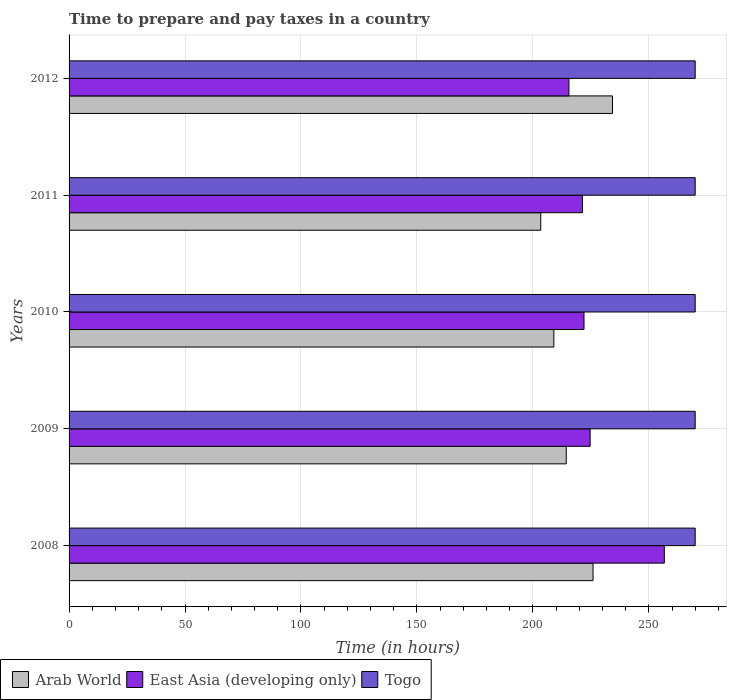How many different coloured bars are there?
Your answer should be very brief. 3. How many groups of bars are there?
Keep it short and to the point. 5. Are the number of bars per tick equal to the number of legend labels?
Ensure brevity in your answer.  Yes. Are the number of bars on each tick of the Y-axis equal?
Offer a very short reply. Yes. How many bars are there on the 3rd tick from the top?
Your response must be concise. 3. How many bars are there on the 4th tick from the bottom?
Your response must be concise. 3. What is the label of the 5th group of bars from the top?
Keep it short and to the point. 2008. In how many cases, is the number of bars for a given year not equal to the number of legend labels?
Provide a succinct answer. 0. What is the number of hours required to prepare and pay taxes in East Asia (developing only) in 2012?
Your answer should be compact. 215.55. Across all years, what is the maximum number of hours required to prepare and pay taxes in Togo?
Give a very brief answer. 270. Across all years, what is the minimum number of hours required to prepare and pay taxes in Arab World?
Your response must be concise. 203.4. What is the total number of hours required to prepare and pay taxes in Togo in the graph?
Give a very brief answer. 1350. What is the difference between the number of hours required to prepare and pay taxes in East Asia (developing only) in 2010 and that in 2011?
Give a very brief answer. 0.67. What is the difference between the number of hours required to prepare and pay taxes in Togo in 2010 and the number of hours required to prepare and pay taxes in East Asia (developing only) in 2012?
Ensure brevity in your answer.  54.45. What is the average number of hours required to prepare and pay taxes in Togo per year?
Make the answer very short. 270. In the year 2010, what is the difference between the number of hours required to prepare and pay taxes in Togo and number of hours required to prepare and pay taxes in Arab World?
Your answer should be very brief. 60.95. What is the ratio of the number of hours required to prepare and pay taxes in East Asia (developing only) in 2008 to that in 2010?
Ensure brevity in your answer.  1.16. What is the difference between the highest and the second highest number of hours required to prepare and pay taxes in East Asia (developing only)?
Give a very brief answer. 32. What is the difference between the highest and the lowest number of hours required to prepare and pay taxes in East Asia (developing only)?
Provide a short and direct response. 41.14. In how many years, is the number of hours required to prepare and pay taxes in Arab World greater than the average number of hours required to prepare and pay taxes in Arab World taken over all years?
Offer a terse response. 2. What does the 1st bar from the top in 2008 represents?
Give a very brief answer. Togo. What does the 1st bar from the bottom in 2010 represents?
Give a very brief answer. Arab World. How many bars are there?
Offer a terse response. 15. Are all the bars in the graph horizontal?
Your response must be concise. Yes. What is the difference between two consecutive major ticks on the X-axis?
Provide a succinct answer. 50. Does the graph contain grids?
Keep it short and to the point. Yes. Where does the legend appear in the graph?
Provide a succinct answer. Bottom left. How many legend labels are there?
Offer a terse response. 3. What is the title of the graph?
Provide a succinct answer. Time to prepare and pay taxes in a country. What is the label or title of the X-axis?
Provide a succinct answer. Time (in hours). What is the label or title of the Y-axis?
Your answer should be very brief. Years. What is the Time (in hours) of Arab World in 2008?
Make the answer very short. 225.95. What is the Time (in hours) of East Asia (developing only) in 2008?
Ensure brevity in your answer.  256.69. What is the Time (in hours) of Togo in 2008?
Give a very brief answer. 270. What is the Time (in hours) of Arab World in 2009?
Keep it short and to the point. 214.4. What is the Time (in hours) in East Asia (developing only) in 2009?
Keep it short and to the point. 224.69. What is the Time (in hours) in Togo in 2009?
Ensure brevity in your answer.  270. What is the Time (in hours) of Arab World in 2010?
Offer a terse response. 209.05. What is the Time (in hours) in East Asia (developing only) in 2010?
Your answer should be compact. 222.06. What is the Time (in hours) in Togo in 2010?
Ensure brevity in your answer.  270. What is the Time (in hours) of Arab World in 2011?
Make the answer very short. 203.4. What is the Time (in hours) of East Asia (developing only) in 2011?
Provide a succinct answer. 221.39. What is the Time (in hours) of Togo in 2011?
Your answer should be compact. 270. What is the Time (in hours) of Arab World in 2012?
Give a very brief answer. 234.33. What is the Time (in hours) of East Asia (developing only) in 2012?
Provide a short and direct response. 215.55. What is the Time (in hours) in Togo in 2012?
Offer a very short reply. 270. Across all years, what is the maximum Time (in hours) in Arab World?
Provide a short and direct response. 234.33. Across all years, what is the maximum Time (in hours) in East Asia (developing only)?
Your answer should be very brief. 256.69. Across all years, what is the maximum Time (in hours) in Togo?
Provide a short and direct response. 270. Across all years, what is the minimum Time (in hours) of Arab World?
Give a very brief answer. 203.4. Across all years, what is the minimum Time (in hours) in East Asia (developing only)?
Ensure brevity in your answer.  215.55. Across all years, what is the minimum Time (in hours) of Togo?
Make the answer very short. 270. What is the total Time (in hours) in Arab World in the graph?
Provide a succinct answer. 1087.13. What is the total Time (in hours) in East Asia (developing only) in the graph?
Your response must be concise. 1140.39. What is the total Time (in hours) of Togo in the graph?
Give a very brief answer. 1350. What is the difference between the Time (in hours) of Arab World in 2008 and that in 2009?
Keep it short and to the point. 11.55. What is the difference between the Time (in hours) in East Asia (developing only) in 2008 and that in 2009?
Your answer should be very brief. 32. What is the difference between the Time (in hours) in Togo in 2008 and that in 2009?
Offer a very short reply. 0. What is the difference between the Time (in hours) of East Asia (developing only) in 2008 and that in 2010?
Your answer should be compact. 34.64. What is the difference between the Time (in hours) of Togo in 2008 and that in 2010?
Offer a terse response. 0. What is the difference between the Time (in hours) in Arab World in 2008 and that in 2011?
Your response must be concise. 22.55. What is the difference between the Time (in hours) of East Asia (developing only) in 2008 and that in 2011?
Offer a terse response. 35.31. What is the difference between the Time (in hours) in Togo in 2008 and that in 2011?
Provide a short and direct response. 0. What is the difference between the Time (in hours) of Arab World in 2008 and that in 2012?
Make the answer very short. -8.38. What is the difference between the Time (in hours) of East Asia (developing only) in 2008 and that in 2012?
Provide a short and direct response. 41.14. What is the difference between the Time (in hours) of Arab World in 2009 and that in 2010?
Offer a very short reply. 5.35. What is the difference between the Time (in hours) of East Asia (developing only) in 2009 and that in 2010?
Offer a very short reply. 2.64. What is the difference between the Time (in hours) of Togo in 2009 and that in 2010?
Provide a succinct answer. 0. What is the difference between the Time (in hours) of East Asia (developing only) in 2009 and that in 2011?
Offer a very short reply. 3.31. What is the difference between the Time (in hours) of Togo in 2009 and that in 2011?
Your answer should be very brief. 0. What is the difference between the Time (in hours) in Arab World in 2009 and that in 2012?
Your answer should be compact. -19.93. What is the difference between the Time (in hours) of East Asia (developing only) in 2009 and that in 2012?
Make the answer very short. 9.14. What is the difference between the Time (in hours) of Togo in 2009 and that in 2012?
Ensure brevity in your answer.  0. What is the difference between the Time (in hours) in Arab World in 2010 and that in 2011?
Your answer should be compact. 5.65. What is the difference between the Time (in hours) in Togo in 2010 and that in 2011?
Ensure brevity in your answer.  0. What is the difference between the Time (in hours) in Arab World in 2010 and that in 2012?
Ensure brevity in your answer.  -25.28. What is the difference between the Time (in hours) of East Asia (developing only) in 2010 and that in 2012?
Provide a succinct answer. 6.5. What is the difference between the Time (in hours) in Arab World in 2011 and that in 2012?
Make the answer very short. -30.93. What is the difference between the Time (in hours) in East Asia (developing only) in 2011 and that in 2012?
Make the answer very short. 5.84. What is the difference between the Time (in hours) in Togo in 2011 and that in 2012?
Offer a terse response. 0. What is the difference between the Time (in hours) in Arab World in 2008 and the Time (in hours) in East Asia (developing only) in 2009?
Give a very brief answer. 1.26. What is the difference between the Time (in hours) of Arab World in 2008 and the Time (in hours) of Togo in 2009?
Your response must be concise. -44.05. What is the difference between the Time (in hours) in East Asia (developing only) in 2008 and the Time (in hours) in Togo in 2009?
Ensure brevity in your answer.  -13.31. What is the difference between the Time (in hours) of Arab World in 2008 and the Time (in hours) of East Asia (developing only) in 2010?
Offer a very short reply. 3.89. What is the difference between the Time (in hours) of Arab World in 2008 and the Time (in hours) of Togo in 2010?
Give a very brief answer. -44.05. What is the difference between the Time (in hours) in East Asia (developing only) in 2008 and the Time (in hours) in Togo in 2010?
Provide a succinct answer. -13.31. What is the difference between the Time (in hours) of Arab World in 2008 and the Time (in hours) of East Asia (developing only) in 2011?
Provide a succinct answer. 4.56. What is the difference between the Time (in hours) of Arab World in 2008 and the Time (in hours) of Togo in 2011?
Give a very brief answer. -44.05. What is the difference between the Time (in hours) in East Asia (developing only) in 2008 and the Time (in hours) in Togo in 2011?
Offer a terse response. -13.31. What is the difference between the Time (in hours) of Arab World in 2008 and the Time (in hours) of East Asia (developing only) in 2012?
Give a very brief answer. 10.4. What is the difference between the Time (in hours) in Arab World in 2008 and the Time (in hours) in Togo in 2012?
Ensure brevity in your answer.  -44.05. What is the difference between the Time (in hours) of East Asia (developing only) in 2008 and the Time (in hours) of Togo in 2012?
Ensure brevity in your answer.  -13.31. What is the difference between the Time (in hours) in Arab World in 2009 and the Time (in hours) in East Asia (developing only) in 2010?
Ensure brevity in your answer.  -7.66. What is the difference between the Time (in hours) in Arab World in 2009 and the Time (in hours) in Togo in 2010?
Offer a very short reply. -55.6. What is the difference between the Time (in hours) in East Asia (developing only) in 2009 and the Time (in hours) in Togo in 2010?
Your response must be concise. -45.31. What is the difference between the Time (in hours) of Arab World in 2009 and the Time (in hours) of East Asia (developing only) in 2011?
Make the answer very short. -6.99. What is the difference between the Time (in hours) of Arab World in 2009 and the Time (in hours) of Togo in 2011?
Give a very brief answer. -55.6. What is the difference between the Time (in hours) of East Asia (developing only) in 2009 and the Time (in hours) of Togo in 2011?
Make the answer very short. -45.31. What is the difference between the Time (in hours) of Arab World in 2009 and the Time (in hours) of East Asia (developing only) in 2012?
Your answer should be compact. -1.15. What is the difference between the Time (in hours) in Arab World in 2009 and the Time (in hours) in Togo in 2012?
Your response must be concise. -55.6. What is the difference between the Time (in hours) in East Asia (developing only) in 2009 and the Time (in hours) in Togo in 2012?
Offer a terse response. -45.31. What is the difference between the Time (in hours) of Arab World in 2010 and the Time (in hours) of East Asia (developing only) in 2011?
Your response must be concise. -12.34. What is the difference between the Time (in hours) of Arab World in 2010 and the Time (in hours) of Togo in 2011?
Your answer should be very brief. -60.95. What is the difference between the Time (in hours) of East Asia (developing only) in 2010 and the Time (in hours) of Togo in 2011?
Offer a very short reply. -47.94. What is the difference between the Time (in hours) of Arab World in 2010 and the Time (in hours) of East Asia (developing only) in 2012?
Ensure brevity in your answer.  -6.5. What is the difference between the Time (in hours) in Arab World in 2010 and the Time (in hours) in Togo in 2012?
Offer a terse response. -60.95. What is the difference between the Time (in hours) of East Asia (developing only) in 2010 and the Time (in hours) of Togo in 2012?
Provide a succinct answer. -47.94. What is the difference between the Time (in hours) in Arab World in 2011 and the Time (in hours) in East Asia (developing only) in 2012?
Your answer should be very brief. -12.15. What is the difference between the Time (in hours) in Arab World in 2011 and the Time (in hours) in Togo in 2012?
Your answer should be compact. -66.6. What is the difference between the Time (in hours) of East Asia (developing only) in 2011 and the Time (in hours) of Togo in 2012?
Provide a short and direct response. -48.61. What is the average Time (in hours) in Arab World per year?
Ensure brevity in your answer.  217.43. What is the average Time (in hours) in East Asia (developing only) per year?
Give a very brief answer. 228.08. What is the average Time (in hours) of Togo per year?
Make the answer very short. 270. In the year 2008, what is the difference between the Time (in hours) of Arab World and Time (in hours) of East Asia (developing only)?
Give a very brief answer. -30.74. In the year 2008, what is the difference between the Time (in hours) in Arab World and Time (in hours) in Togo?
Provide a short and direct response. -44.05. In the year 2008, what is the difference between the Time (in hours) in East Asia (developing only) and Time (in hours) in Togo?
Provide a succinct answer. -13.31. In the year 2009, what is the difference between the Time (in hours) of Arab World and Time (in hours) of East Asia (developing only)?
Provide a short and direct response. -10.29. In the year 2009, what is the difference between the Time (in hours) in Arab World and Time (in hours) in Togo?
Your response must be concise. -55.6. In the year 2009, what is the difference between the Time (in hours) in East Asia (developing only) and Time (in hours) in Togo?
Offer a very short reply. -45.31. In the year 2010, what is the difference between the Time (in hours) in Arab World and Time (in hours) in East Asia (developing only)?
Provide a succinct answer. -13.01. In the year 2010, what is the difference between the Time (in hours) in Arab World and Time (in hours) in Togo?
Make the answer very short. -60.95. In the year 2010, what is the difference between the Time (in hours) of East Asia (developing only) and Time (in hours) of Togo?
Your response must be concise. -47.94. In the year 2011, what is the difference between the Time (in hours) in Arab World and Time (in hours) in East Asia (developing only)?
Provide a short and direct response. -17.99. In the year 2011, what is the difference between the Time (in hours) of Arab World and Time (in hours) of Togo?
Give a very brief answer. -66.6. In the year 2011, what is the difference between the Time (in hours) in East Asia (developing only) and Time (in hours) in Togo?
Provide a succinct answer. -48.61. In the year 2012, what is the difference between the Time (in hours) of Arab World and Time (in hours) of East Asia (developing only)?
Your response must be concise. 18.78. In the year 2012, what is the difference between the Time (in hours) of Arab World and Time (in hours) of Togo?
Offer a terse response. -35.67. In the year 2012, what is the difference between the Time (in hours) of East Asia (developing only) and Time (in hours) of Togo?
Provide a short and direct response. -54.45. What is the ratio of the Time (in hours) in Arab World in 2008 to that in 2009?
Your answer should be compact. 1.05. What is the ratio of the Time (in hours) of East Asia (developing only) in 2008 to that in 2009?
Ensure brevity in your answer.  1.14. What is the ratio of the Time (in hours) of Togo in 2008 to that in 2009?
Provide a short and direct response. 1. What is the ratio of the Time (in hours) in Arab World in 2008 to that in 2010?
Keep it short and to the point. 1.08. What is the ratio of the Time (in hours) of East Asia (developing only) in 2008 to that in 2010?
Keep it short and to the point. 1.16. What is the ratio of the Time (in hours) in Arab World in 2008 to that in 2011?
Keep it short and to the point. 1.11. What is the ratio of the Time (in hours) of East Asia (developing only) in 2008 to that in 2011?
Give a very brief answer. 1.16. What is the ratio of the Time (in hours) in Togo in 2008 to that in 2011?
Your answer should be very brief. 1. What is the ratio of the Time (in hours) of Arab World in 2008 to that in 2012?
Offer a terse response. 0.96. What is the ratio of the Time (in hours) in East Asia (developing only) in 2008 to that in 2012?
Give a very brief answer. 1.19. What is the ratio of the Time (in hours) of Arab World in 2009 to that in 2010?
Make the answer very short. 1.03. What is the ratio of the Time (in hours) in East Asia (developing only) in 2009 to that in 2010?
Offer a very short reply. 1.01. What is the ratio of the Time (in hours) in Togo in 2009 to that in 2010?
Provide a succinct answer. 1. What is the ratio of the Time (in hours) of Arab World in 2009 to that in 2011?
Offer a terse response. 1.05. What is the ratio of the Time (in hours) of East Asia (developing only) in 2009 to that in 2011?
Offer a terse response. 1.01. What is the ratio of the Time (in hours) of Togo in 2009 to that in 2011?
Your response must be concise. 1. What is the ratio of the Time (in hours) in Arab World in 2009 to that in 2012?
Offer a terse response. 0.91. What is the ratio of the Time (in hours) in East Asia (developing only) in 2009 to that in 2012?
Ensure brevity in your answer.  1.04. What is the ratio of the Time (in hours) of Arab World in 2010 to that in 2011?
Your answer should be compact. 1.03. What is the ratio of the Time (in hours) in Togo in 2010 to that in 2011?
Provide a succinct answer. 1. What is the ratio of the Time (in hours) of Arab World in 2010 to that in 2012?
Your response must be concise. 0.89. What is the ratio of the Time (in hours) in East Asia (developing only) in 2010 to that in 2012?
Provide a short and direct response. 1.03. What is the ratio of the Time (in hours) of Togo in 2010 to that in 2012?
Keep it short and to the point. 1. What is the ratio of the Time (in hours) of Arab World in 2011 to that in 2012?
Make the answer very short. 0.87. What is the ratio of the Time (in hours) in East Asia (developing only) in 2011 to that in 2012?
Give a very brief answer. 1.03. What is the ratio of the Time (in hours) in Togo in 2011 to that in 2012?
Your answer should be very brief. 1. What is the difference between the highest and the second highest Time (in hours) of Arab World?
Offer a terse response. 8.38. What is the difference between the highest and the second highest Time (in hours) in Togo?
Provide a succinct answer. 0. What is the difference between the highest and the lowest Time (in hours) of Arab World?
Make the answer very short. 30.93. What is the difference between the highest and the lowest Time (in hours) of East Asia (developing only)?
Offer a terse response. 41.14. 